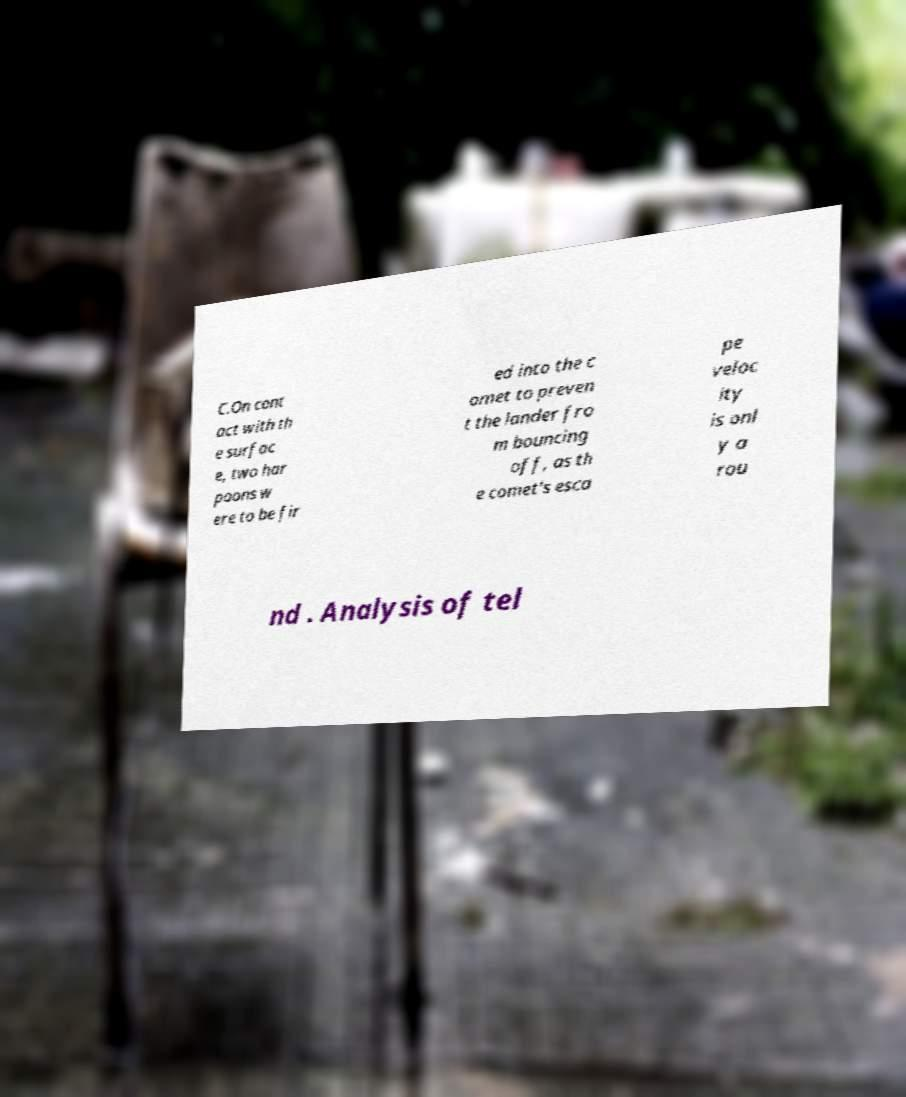Please read and relay the text visible in this image. What does it say? C.On cont act with th e surfac e, two har poons w ere to be fir ed into the c omet to preven t the lander fro m bouncing off, as th e comet's esca pe veloc ity is onl y a rou nd . Analysis of tel 